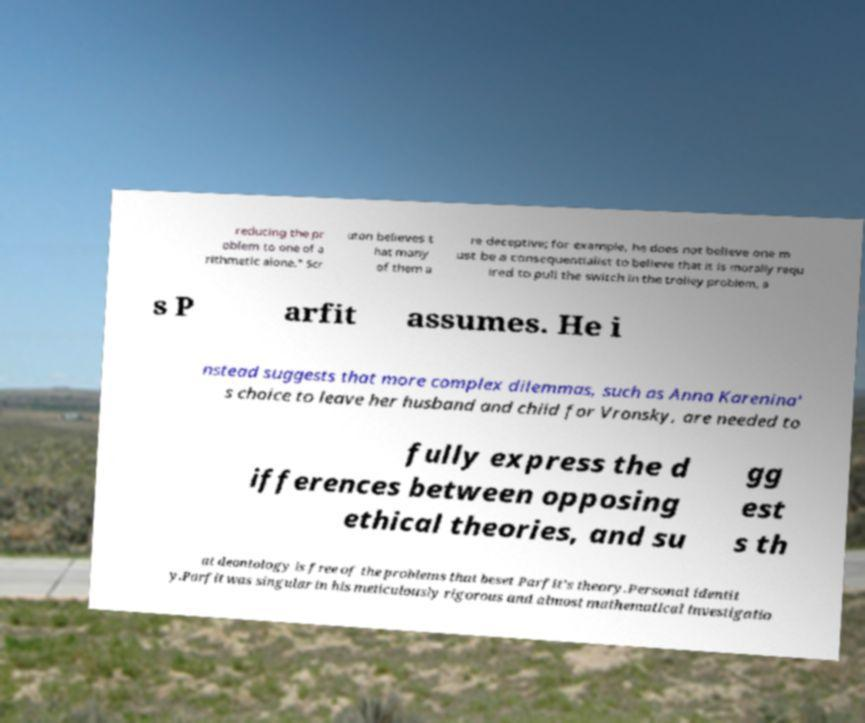Could you assist in decoding the text presented in this image and type it out clearly? reducing the pr oblem to one of a rithmetic alone." Scr uton believes t hat many of them a re deceptive; for example, he does not believe one m ust be a consequentialist to believe that it is morally requ ired to pull the switch in the trolley problem, a s P arfit assumes. He i nstead suggests that more complex dilemmas, such as Anna Karenina' s choice to leave her husband and child for Vronsky, are needed to fully express the d ifferences between opposing ethical theories, and su gg est s th at deontology is free of the problems that beset Parfit's theory.Personal identit y.Parfit was singular in his meticulously rigorous and almost mathematical investigatio 